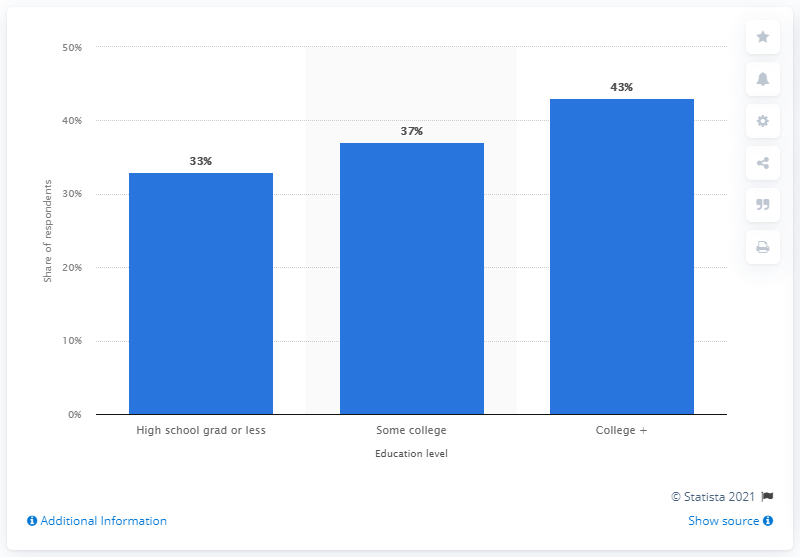Point out several critical features in this image. In February 2019, approximately 80% of U.S. adults who used Instagram also had at least a college education. According to data from February 2019, the highest percentage of U.S. adults who use Instagram have a college education or higher. 